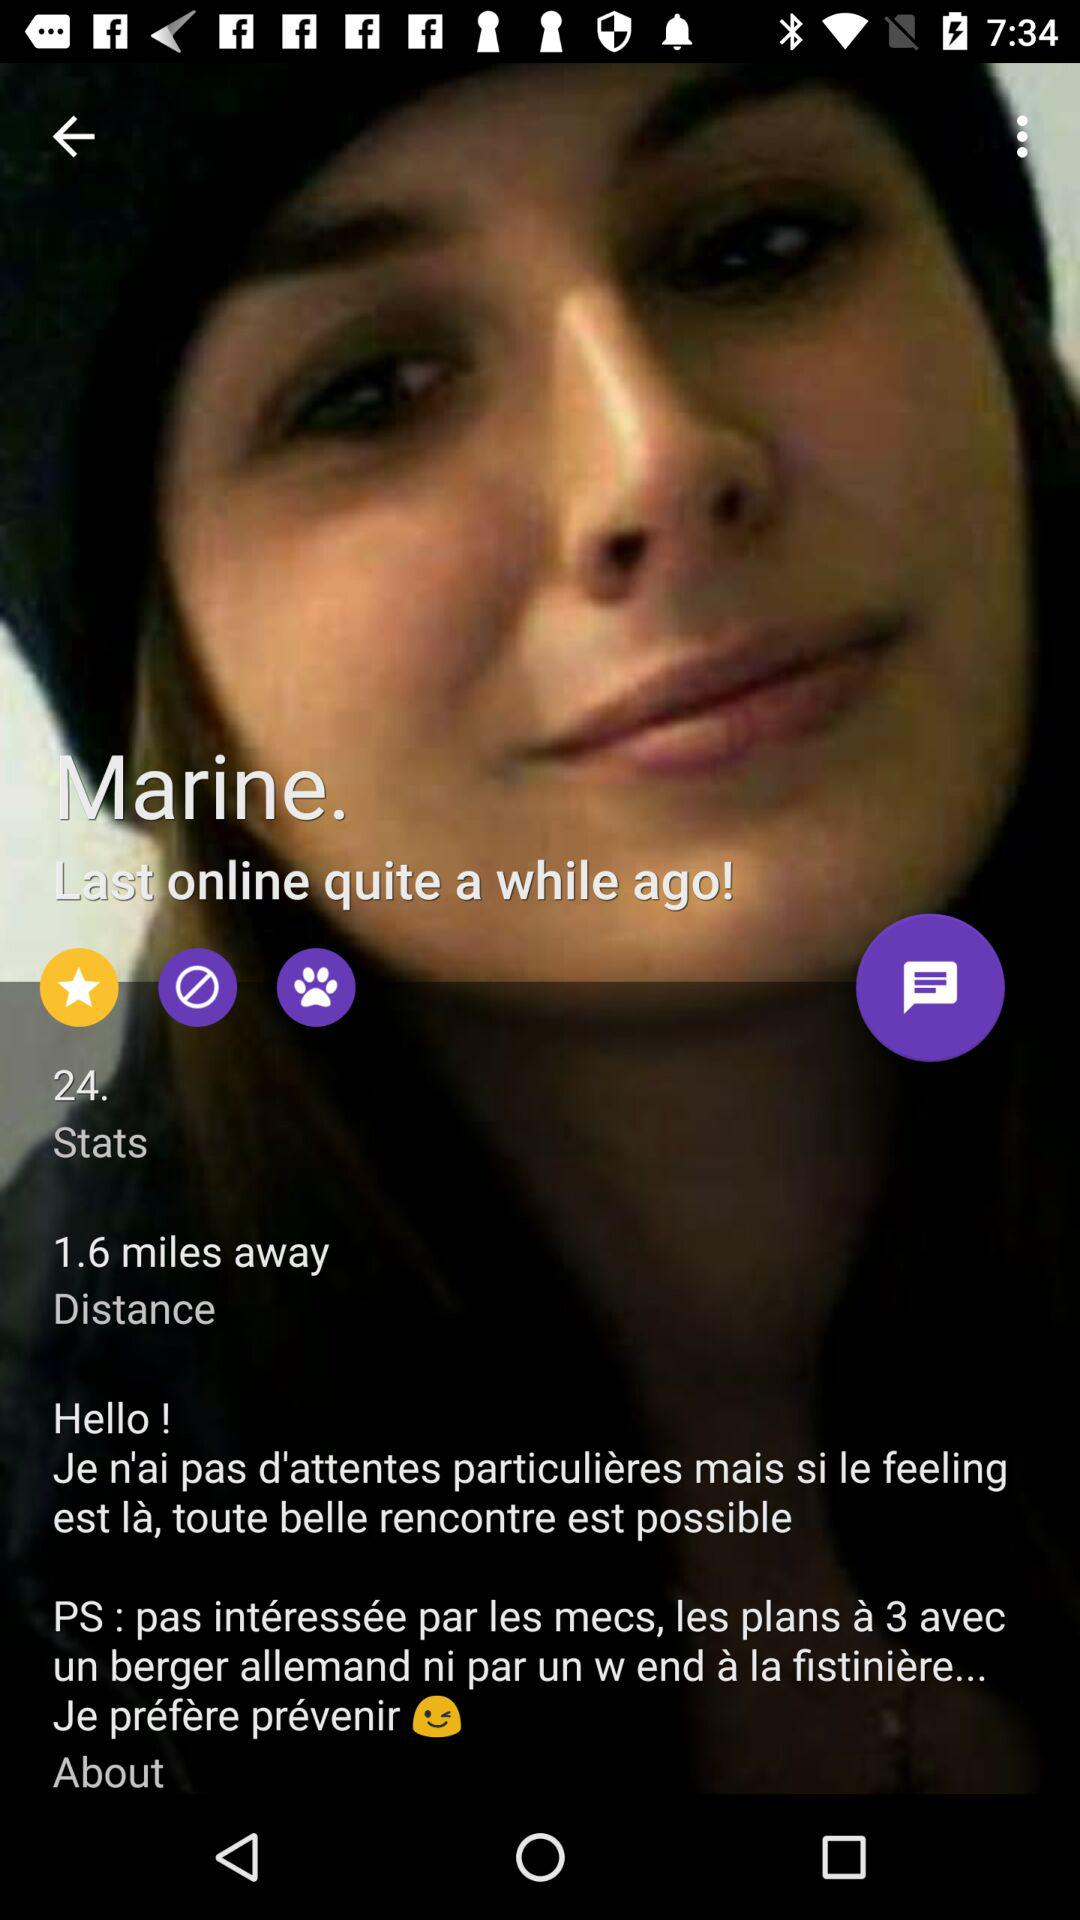What is the name of the user? The name of the user is Marine. 